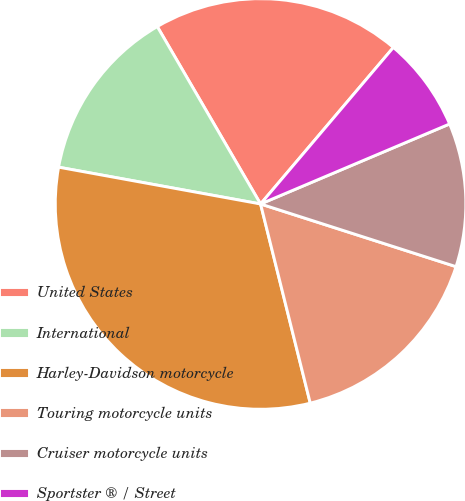Convert chart. <chart><loc_0><loc_0><loc_500><loc_500><pie_chart><fcel>United States<fcel>International<fcel>Harley-Davidson motorcycle<fcel>Touring motorcycle units<fcel>Cruiser motorcycle units<fcel>Sportster ® / Street<nl><fcel>19.59%<fcel>13.74%<fcel>31.76%<fcel>16.17%<fcel>11.31%<fcel>7.43%<nl></chart> 